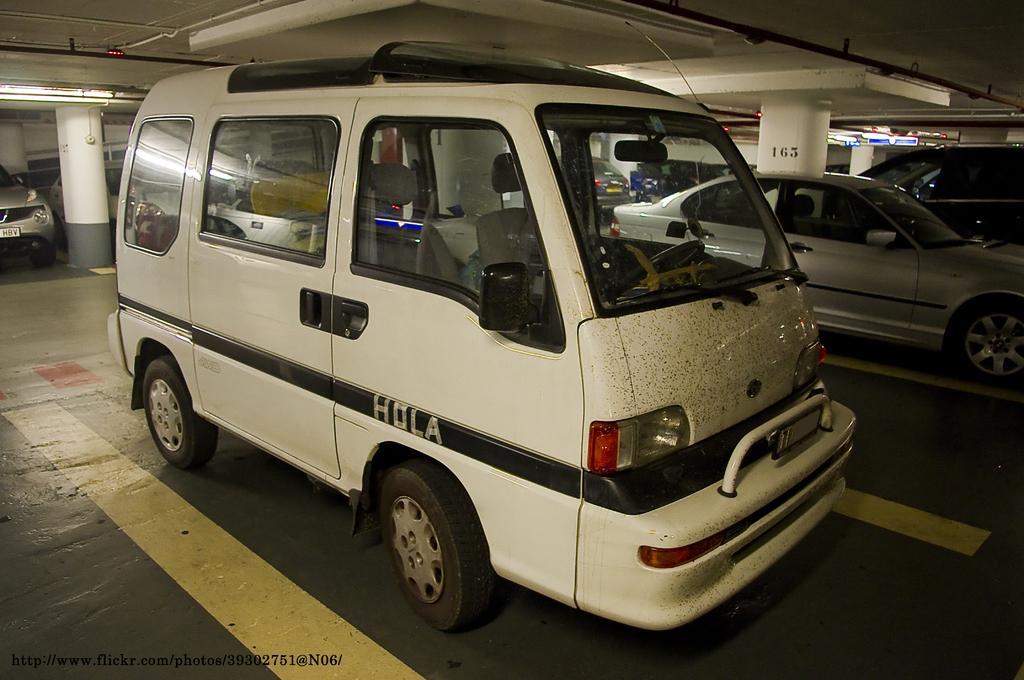How would you summarize this image in a sentence or two? In this image we can see there are many vehicles parked in a parking area. At the top there is a ceiling. 